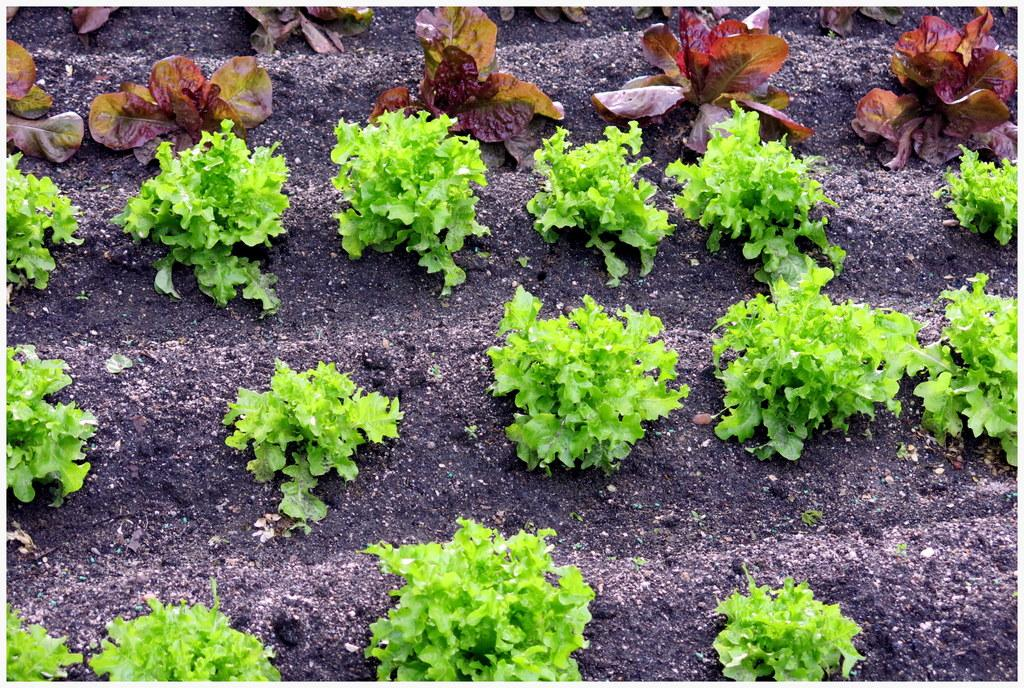What is the primary subject of the image? The primary subject of the image is many plants. Can you describe the soil in the image? There is black soil in the image. What type of oven is used to cook the plants in the image? There is no oven present in the image, as it features plants and soil. What kind of veins can be seen in the plants in the image? The image does not show the internal structure of the plants, so it is not possible to determine if any veins are visible. 